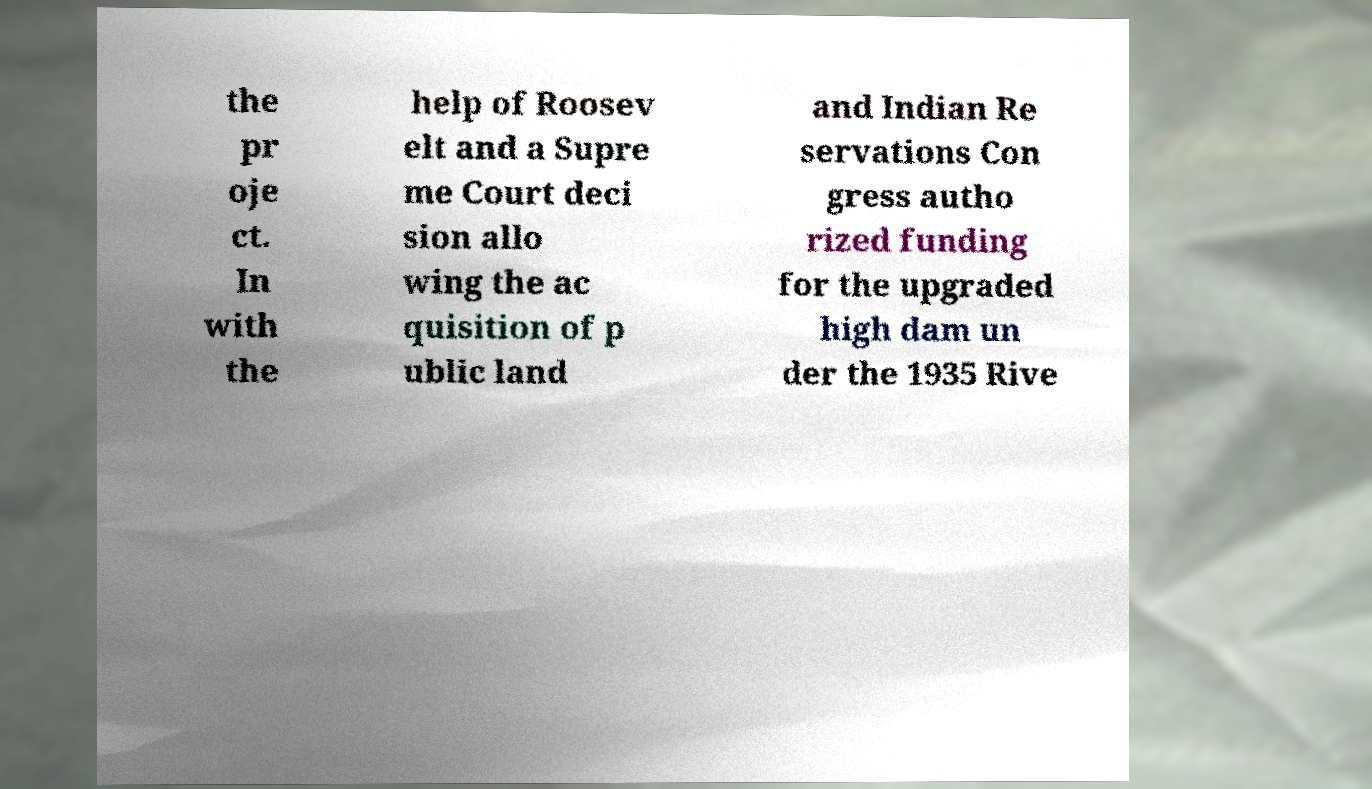Please read and relay the text visible in this image. What does it say? the pr oje ct. In with the help of Roosev elt and a Supre me Court deci sion allo wing the ac quisition of p ublic land and Indian Re servations Con gress autho rized funding for the upgraded high dam un der the 1935 Rive 